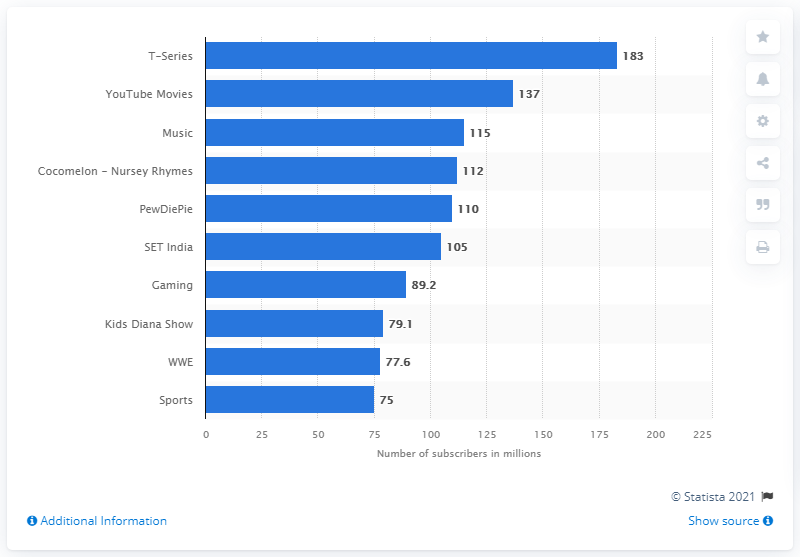Identify some key points in this picture. The two adjacent WWE and Kids Diana Show have the closest number of subscribers. YouTube Movies had 137 subscribers in May 2021. T-Series is the most subscribed YouTube channel in the world. The most popular Youtube channels have an average of 145 subscribers. In May 2021, T-Series had 183 subscribers. 